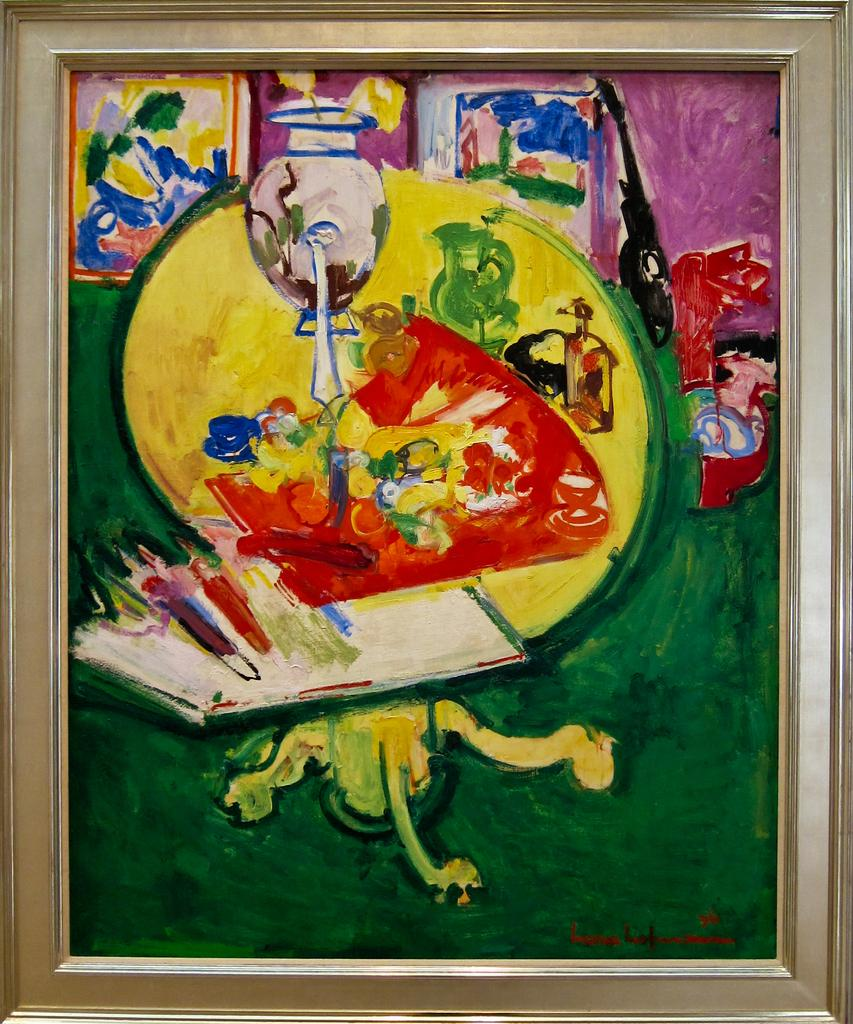What is the main subject of the image? The main subject of the image is a painting. What type of dress is the person wearing in the painting? There is no person or dress visible in the painting; it is a single image of a painting. 